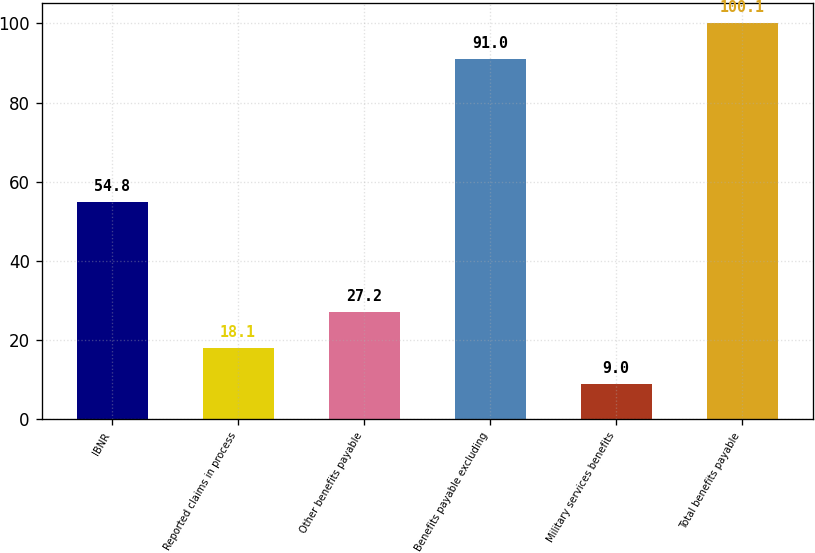<chart> <loc_0><loc_0><loc_500><loc_500><bar_chart><fcel>IBNR<fcel>Reported claims in process<fcel>Other benefits payable<fcel>Benefits payable excluding<fcel>Military services benefits<fcel>Total benefits payable<nl><fcel>54.8<fcel>18.1<fcel>27.2<fcel>91<fcel>9<fcel>100.1<nl></chart> 